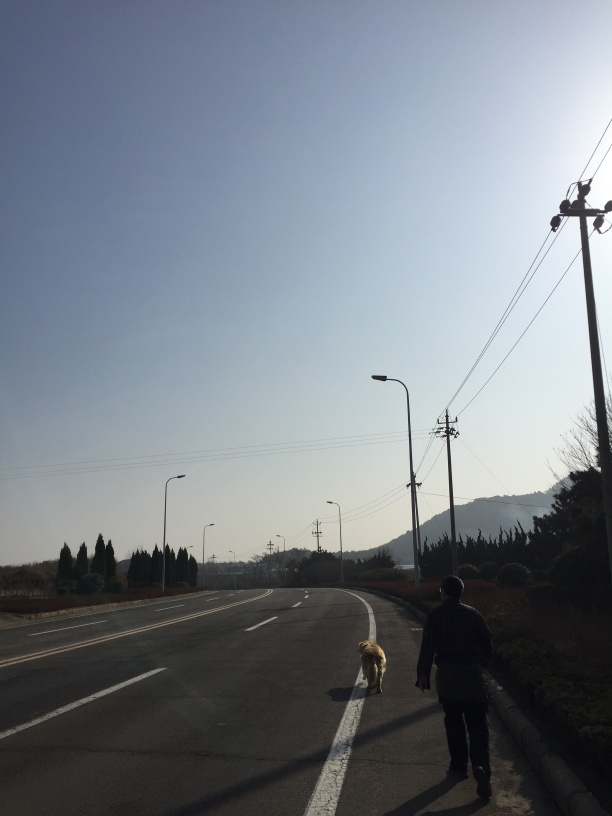What kind of mood does this image evoke? This image evokes a sense of tranquil solitude, underscored by the quiet street, the leisurely pace of the person and their dog, and the serene, open sky above. What elements contribute to that mood? The lack of traffic, the clear road stretching into the distance, and the surrounding natural elements like the line of trees create a peaceful and calm setting. 